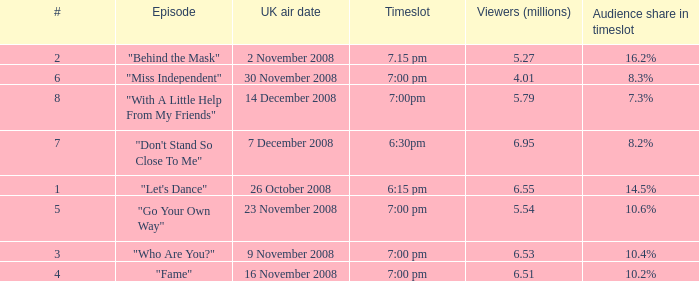Name the total number of viewers for audience share in timeslot for 10.2% 1.0. 